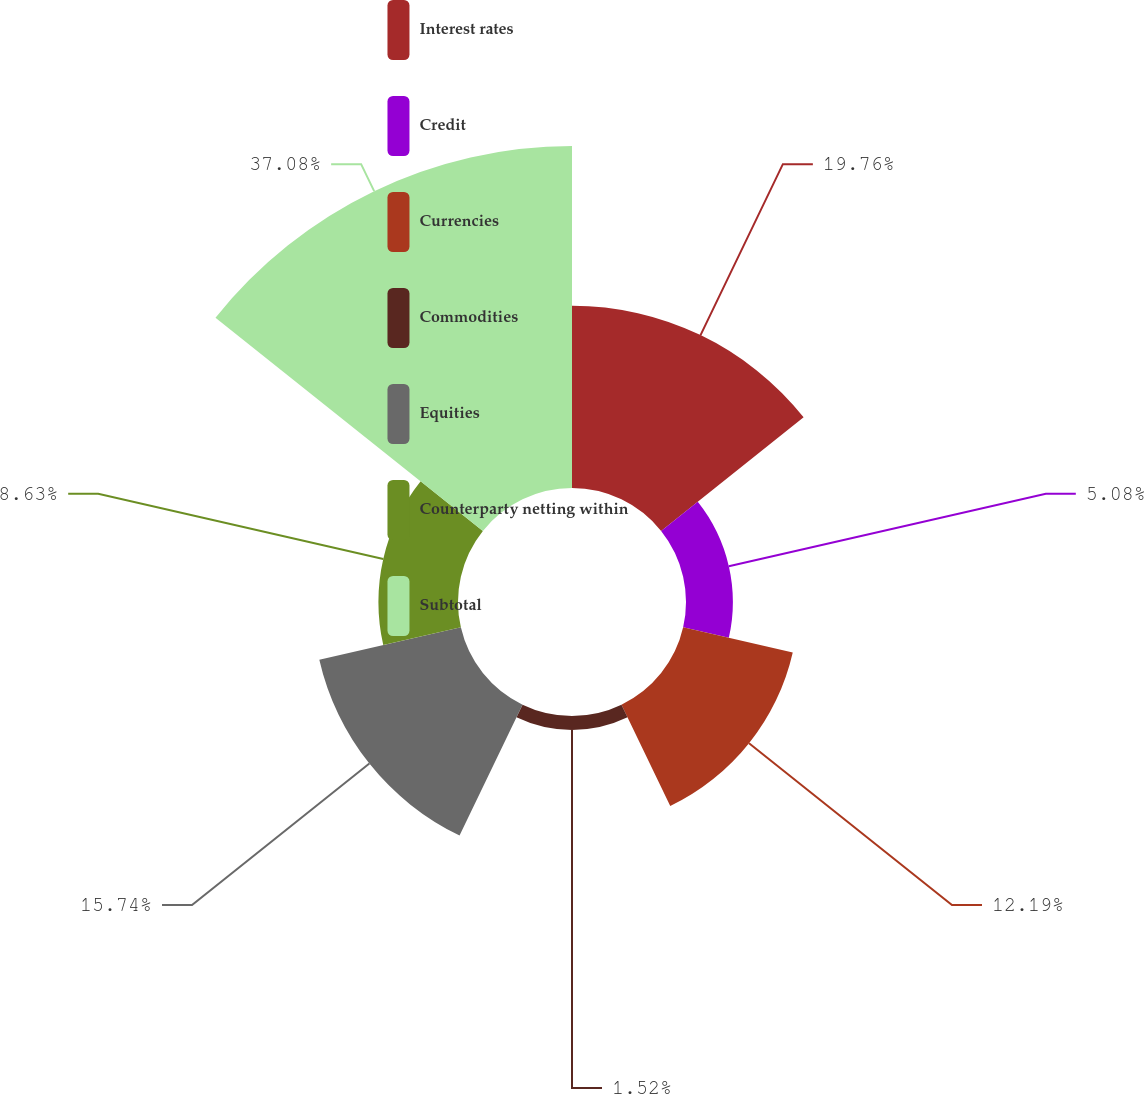Convert chart. <chart><loc_0><loc_0><loc_500><loc_500><pie_chart><fcel>Interest rates<fcel>Credit<fcel>Currencies<fcel>Commodities<fcel>Equities<fcel>Counterparty netting within<fcel>Subtotal<nl><fcel>19.76%<fcel>5.08%<fcel>12.19%<fcel>1.52%<fcel>15.74%<fcel>8.63%<fcel>37.08%<nl></chart> 